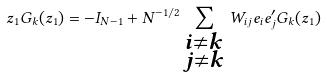<formula> <loc_0><loc_0><loc_500><loc_500>z _ { 1 } G _ { k } ( z _ { 1 } ) = - I _ { N - 1 } + N ^ { - 1 / 2 } \sum _ { \substack { i \neq k \\ j \neq k } } W _ { i j } e _ { i } e _ { j } ^ { \prime } G _ { k } ( z _ { 1 } )</formula> 